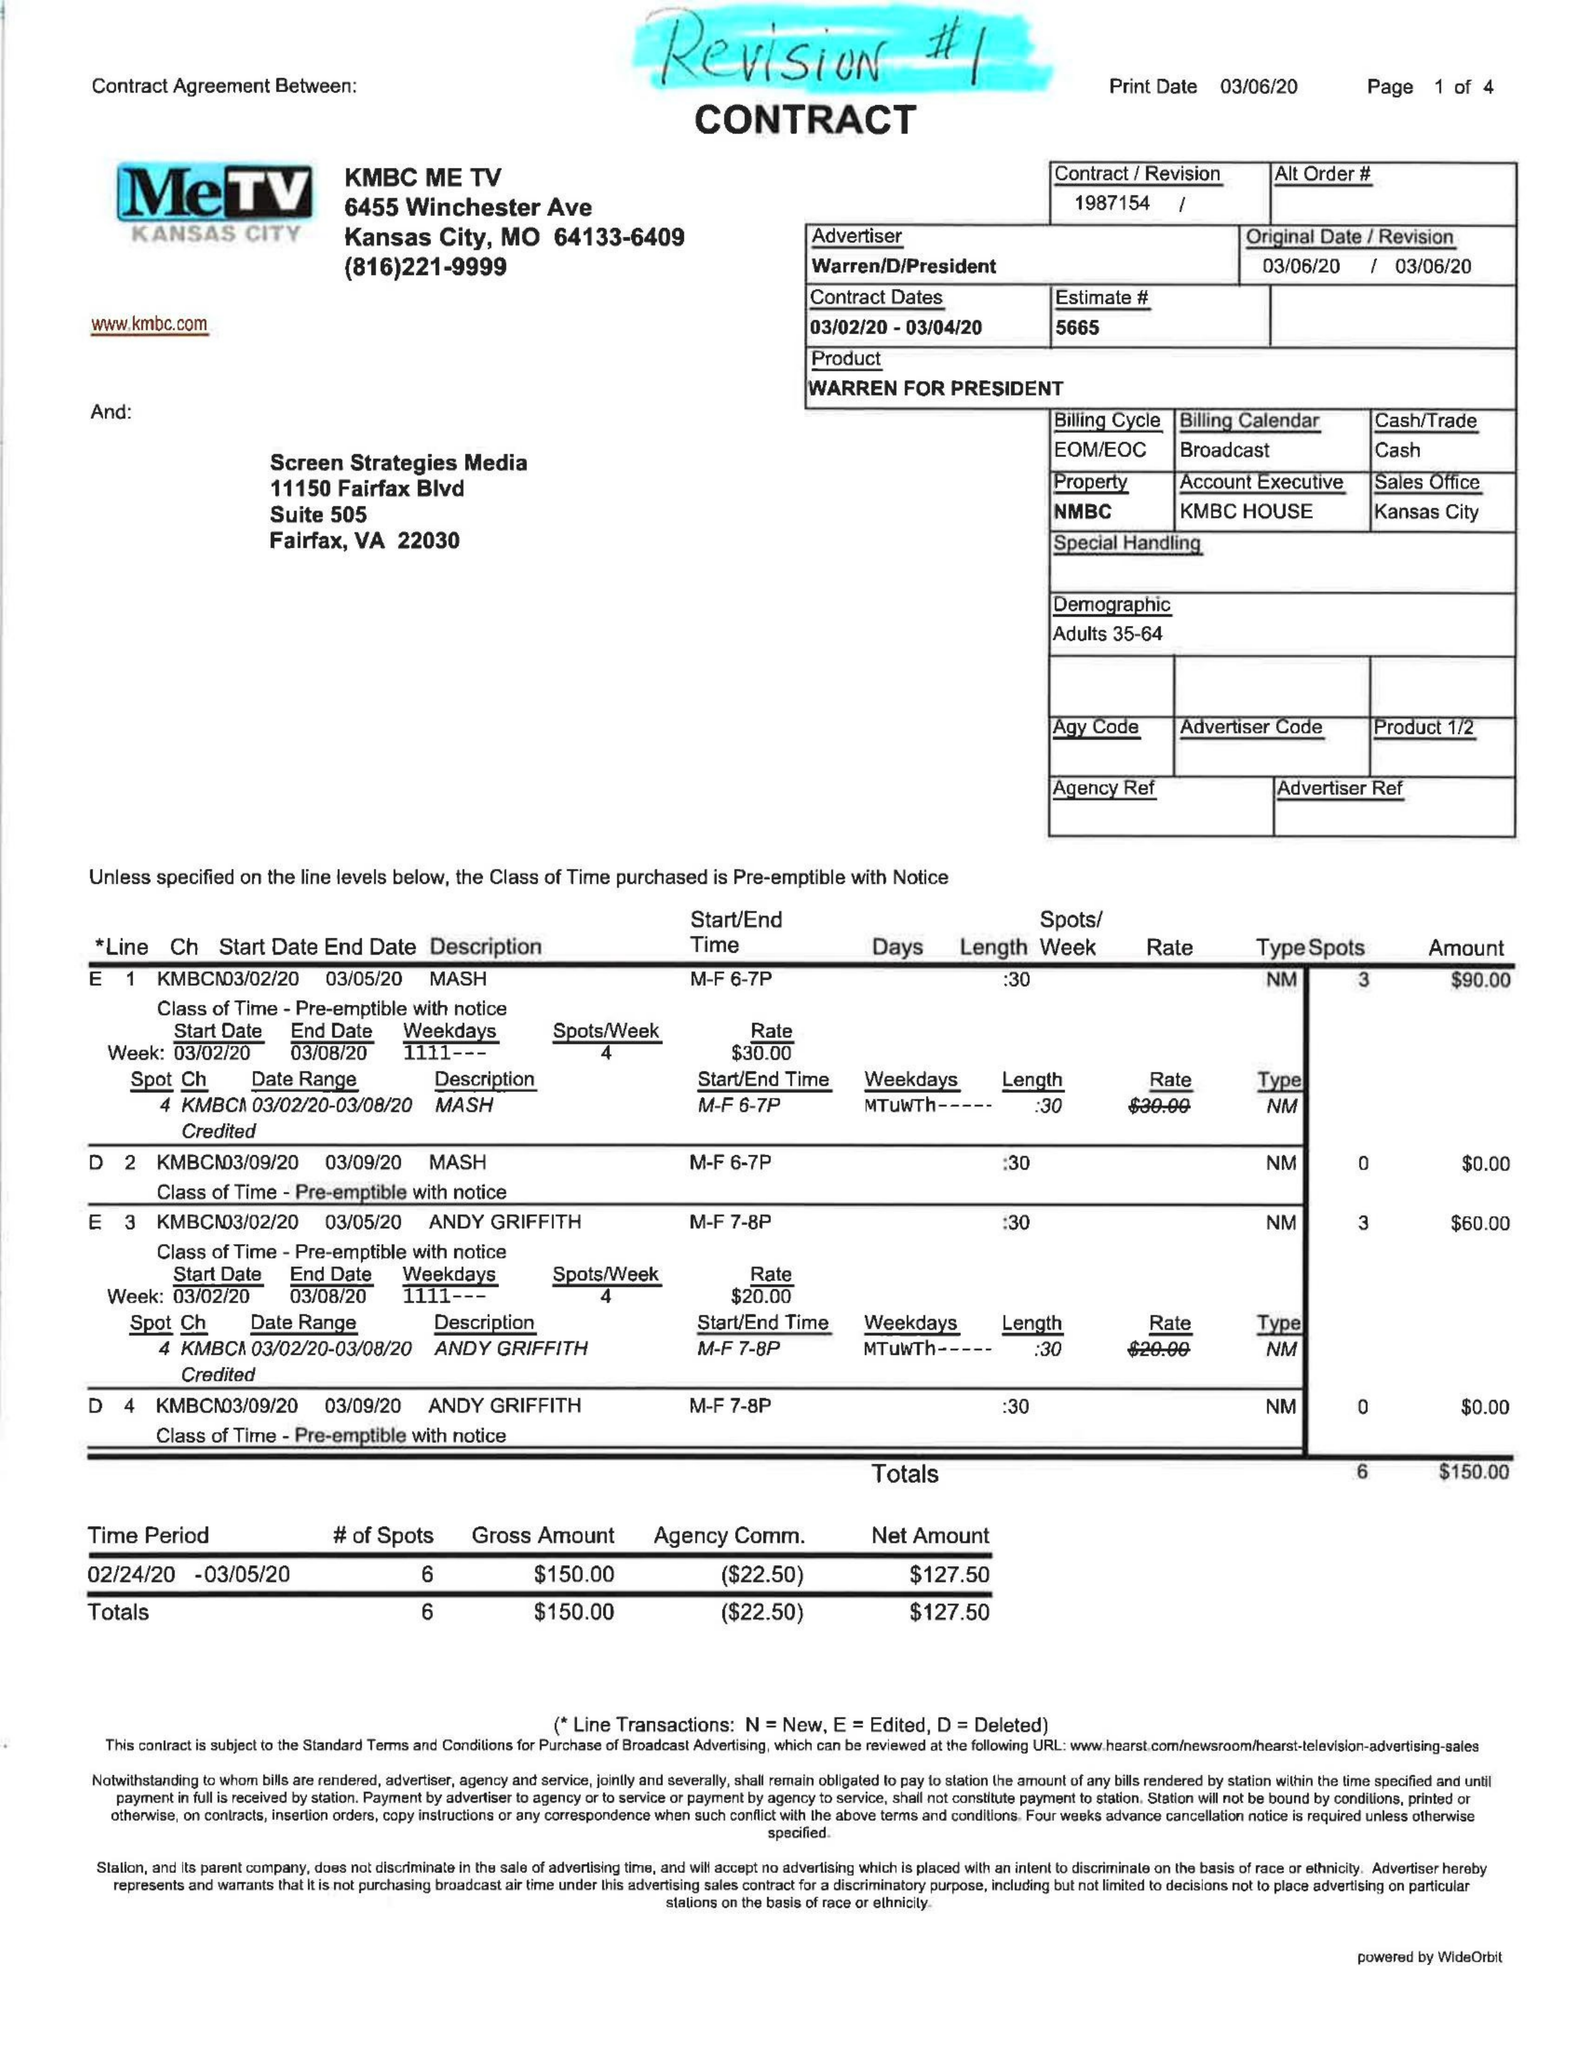What is the value for the contract_num?
Answer the question using a single word or phrase. 1987154 